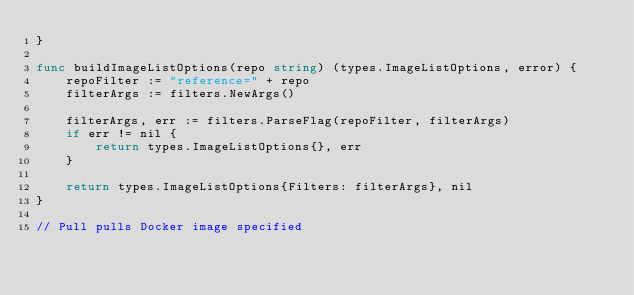<code> <loc_0><loc_0><loc_500><loc_500><_Go_>}

func buildImageListOptions(repo string) (types.ImageListOptions, error) {
	repoFilter := "reference=" + repo
	filterArgs := filters.NewArgs()

	filterArgs, err := filters.ParseFlag(repoFilter, filterArgs)
	if err != nil {
		return types.ImageListOptions{}, err
	}

	return types.ImageListOptions{Filters: filterArgs}, nil
}

// Pull pulls Docker image specified</code> 